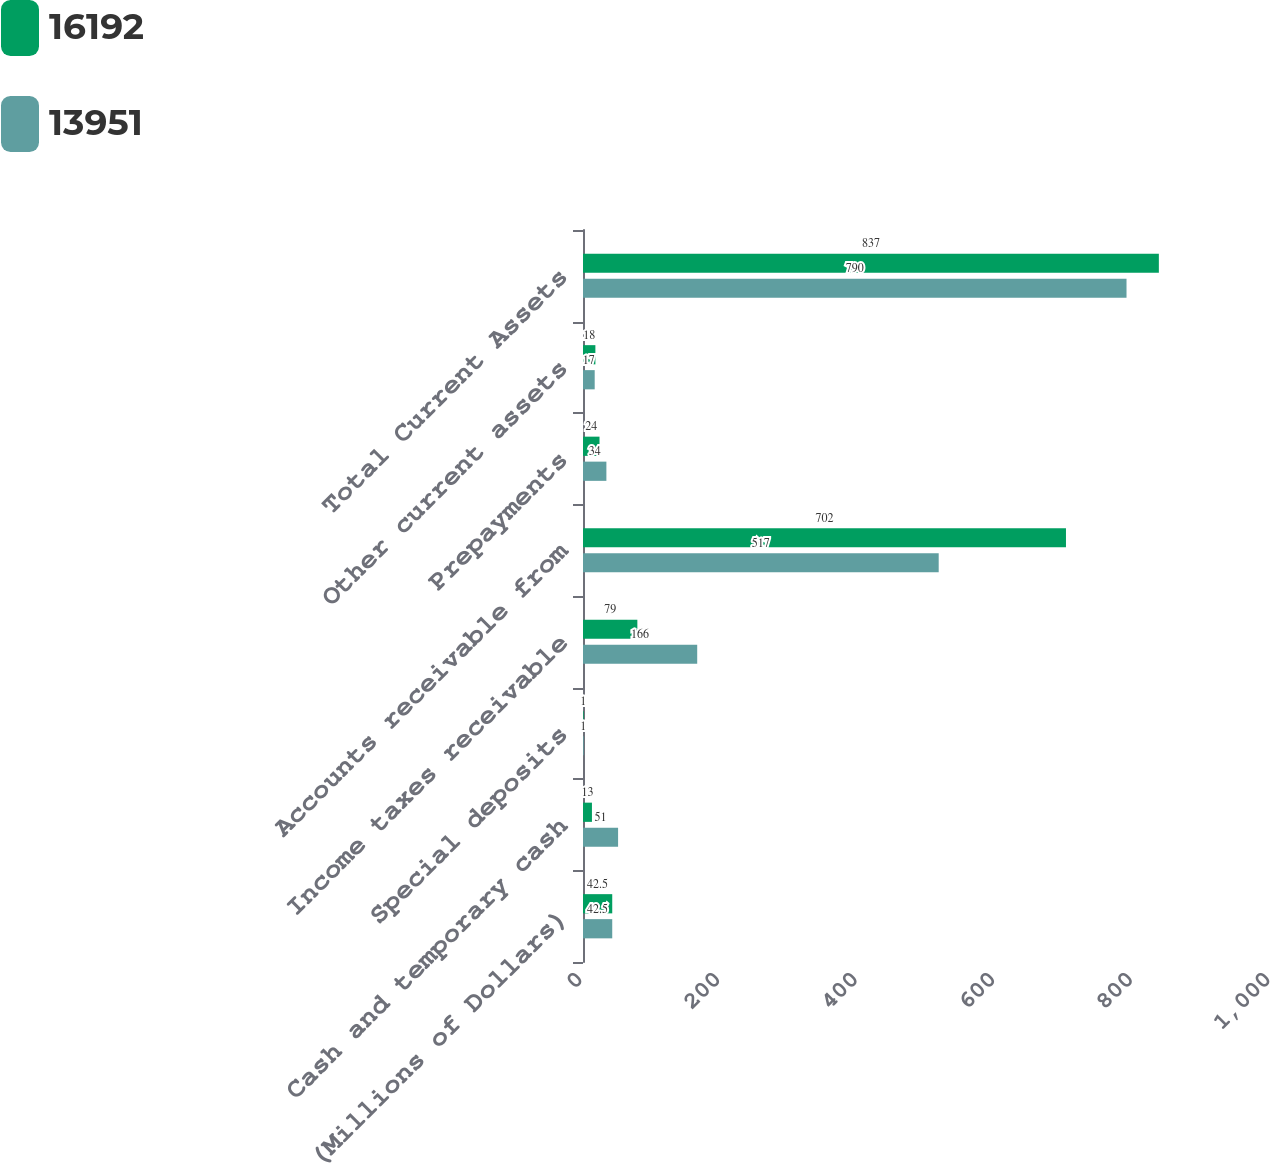<chart> <loc_0><loc_0><loc_500><loc_500><stacked_bar_chart><ecel><fcel>(Millions of Dollars)<fcel>Cash and temporary cash<fcel>Special deposits<fcel>Income taxes receivable<fcel>Accounts receivable from<fcel>Prepayments<fcel>Other current assets<fcel>Total Current Assets<nl><fcel>16192<fcel>42.5<fcel>13<fcel>1<fcel>79<fcel>702<fcel>24<fcel>18<fcel>837<nl><fcel>13951<fcel>42.5<fcel>51<fcel>1<fcel>166<fcel>517<fcel>34<fcel>17<fcel>790<nl></chart> 